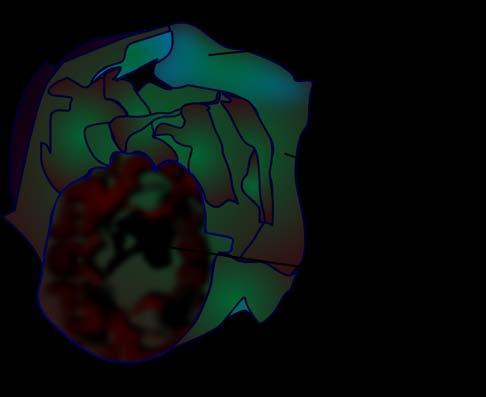what shows presence of loculi containing gelatinous mucoid material?
Answer the question using a single word or phrase. The cyst wall 